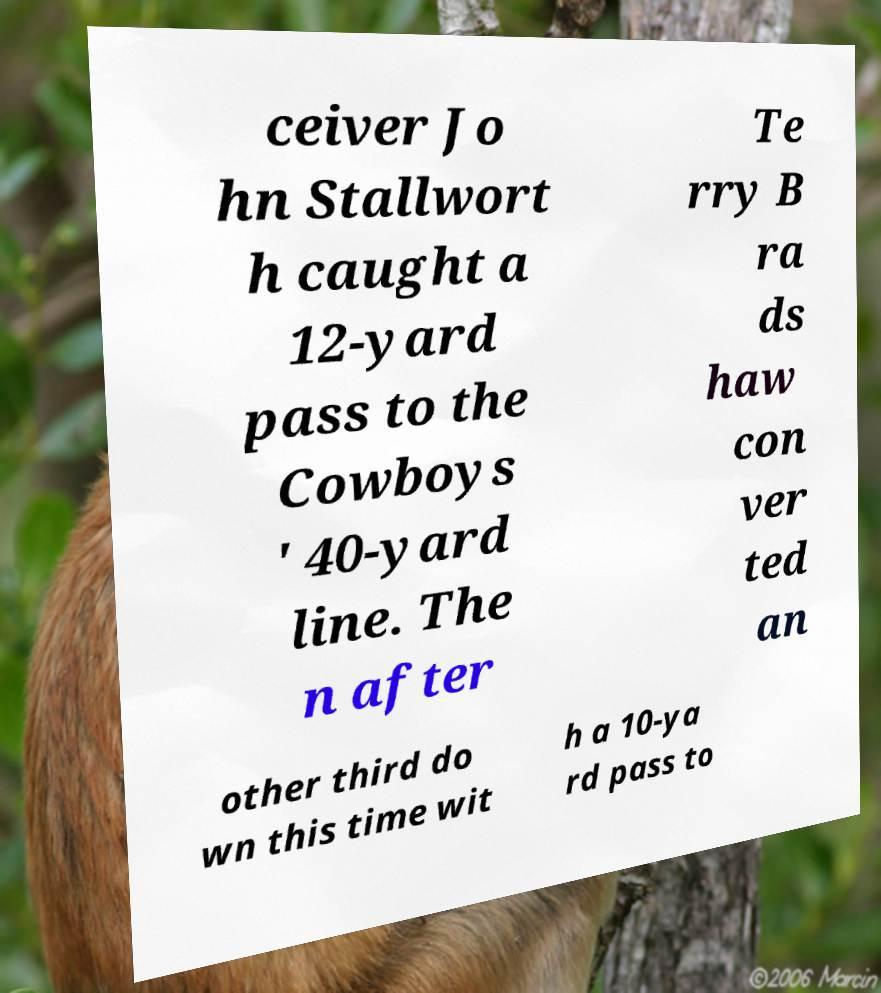Please identify and transcribe the text found in this image. ceiver Jo hn Stallwort h caught a 12-yard pass to the Cowboys ' 40-yard line. The n after Te rry B ra ds haw con ver ted an other third do wn this time wit h a 10-ya rd pass to 